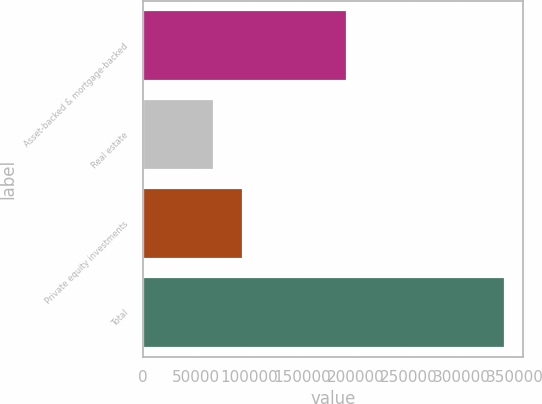Convert chart to OTSL. <chart><loc_0><loc_0><loc_500><loc_500><bar_chart><fcel>Asset-backed & mortgage-backed<fcel>Real estate<fcel>Private equity investments<fcel>Total<nl><fcel>191831<fcel>66704<fcel>94096.9<fcel>340633<nl></chart> 